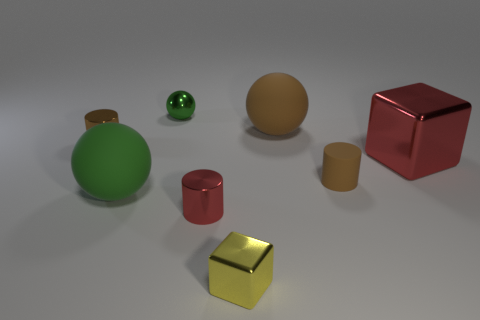There is a large thing that is the same color as the small metal ball; what is it made of?
Ensure brevity in your answer.  Rubber. What material is the brown sphere that is the same size as the green matte object?
Your answer should be very brief. Rubber. Are there any red rubber objects of the same size as the green rubber ball?
Your answer should be compact. No. Are there fewer green balls right of the tiny shiny ball than yellow metal cubes?
Ensure brevity in your answer.  Yes. Are there fewer metal cylinders right of the large red shiny object than green rubber spheres behind the brown shiny object?
Your answer should be very brief. No. How many spheres are either red metal things or tiny red objects?
Your answer should be compact. 0. Does the red thing that is in front of the green rubber thing have the same material as the cylinder on the left side of the red cylinder?
Your response must be concise. Yes. There is a brown shiny thing that is the same size as the yellow metallic object; what is its shape?
Offer a very short reply. Cylinder. What number of other objects are the same color as the matte cylinder?
Provide a succinct answer. 2. What number of green objects are large spheres or tiny blocks?
Make the answer very short. 1. 